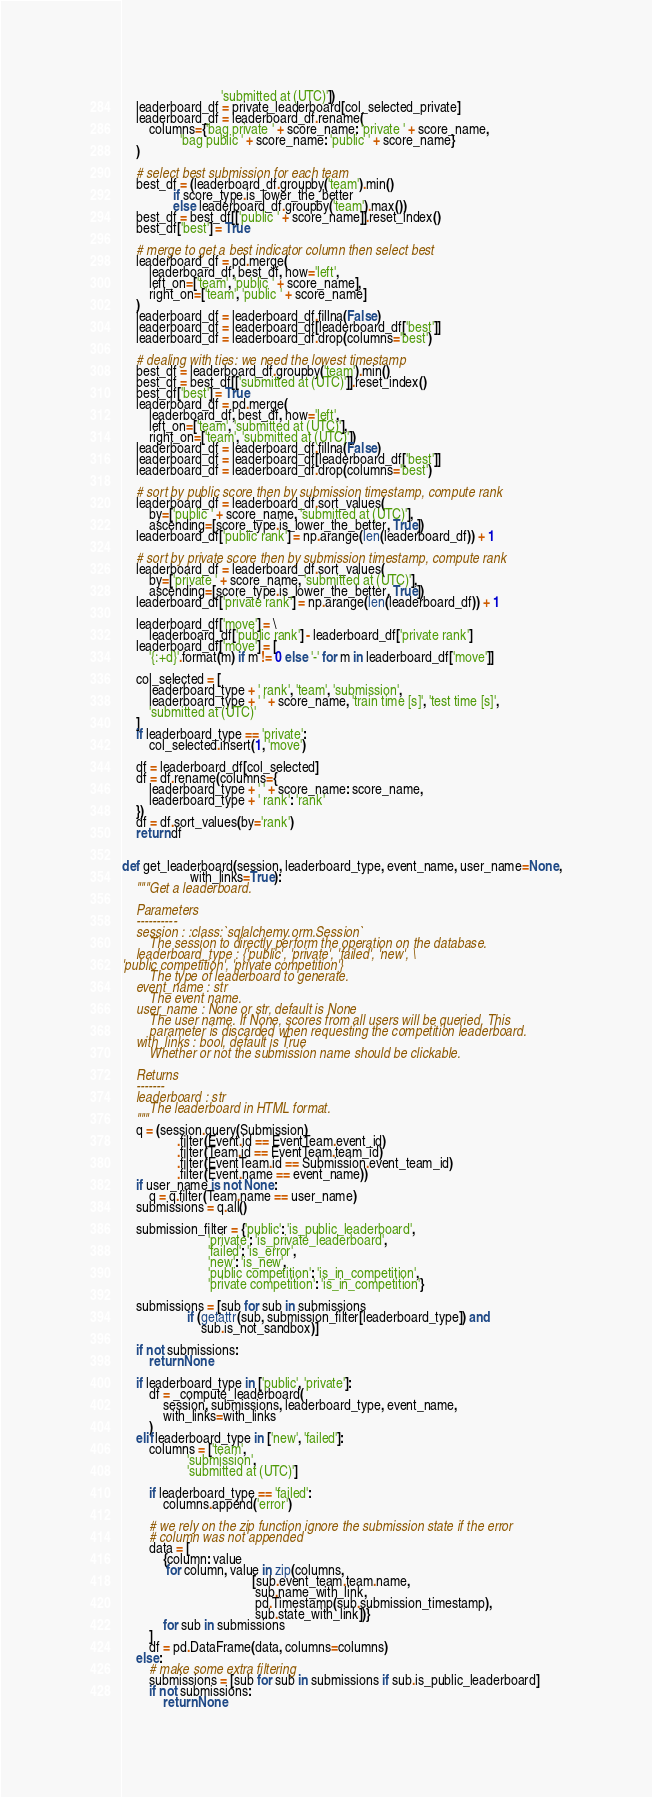<code> <loc_0><loc_0><loc_500><loc_500><_Python_>                             'submitted at (UTC)'])
    leaderboard_df = private_leaderboard[col_selected_private]
    leaderboard_df = leaderboard_df.rename(
        columns={'bag private ' + score_name: 'private ' + score_name,
                 'bag public ' + score_name: 'public ' + score_name}
    )

    # select best submission for each team
    best_df = (leaderboard_df.groupby('team').min()
               if score_type.is_lower_the_better
               else leaderboard_df.groupby('team').max())
    best_df = best_df[['public ' + score_name]].reset_index()
    best_df['best'] = True

    # merge to get a best indicator column then select best
    leaderboard_df = pd.merge(
        leaderboard_df, best_df, how='left',
        left_on=['team', 'public ' + score_name],
        right_on=['team', 'public ' + score_name]
    )
    leaderboard_df = leaderboard_df.fillna(False)
    leaderboard_df = leaderboard_df[leaderboard_df['best']]
    leaderboard_df = leaderboard_df.drop(columns='best')

    # dealing with ties: we need the lowest timestamp
    best_df = leaderboard_df.groupby('team').min()
    best_df = best_df[['submitted at (UTC)']].reset_index()
    best_df['best'] = True
    leaderboard_df = pd.merge(
        leaderboard_df, best_df, how='left',
        left_on=['team', 'submitted at (UTC)'],
        right_on=['team', 'submitted at (UTC)'])
    leaderboard_df = leaderboard_df.fillna(False)
    leaderboard_df = leaderboard_df[leaderboard_df['best']]
    leaderboard_df = leaderboard_df.drop(columns='best')

    # sort by public score then by submission timestamp, compute rank
    leaderboard_df = leaderboard_df.sort_values(
        by=['public ' + score_name, 'submitted at (UTC)'],
        ascending=[score_type.is_lower_the_better, True])
    leaderboard_df['public rank'] = np.arange(len(leaderboard_df)) + 1

    # sort by private score then by submission timestamp, compute rank
    leaderboard_df = leaderboard_df.sort_values(
        by=['private ' + score_name, 'submitted at (UTC)'],
        ascending=[score_type.is_lower_the_better, True])
    leaderboard_df['private rank'] = np.arange(len(leaderboard_df)) + 1

    leaderboard_df['move'] = \
        leaderboard_df['public rank'] - leaderboard_df['private rank']
    leaderboard_df['move'] = [
        '{:+d}'.format(m) if m != 0 else '-' for m in leaderboard_df['move']]

    col_selected = [
        leaderboard_type + ' rank', 'team', 'submission',
        leaderboard_type + ' ' + score_name, 'train time [s]', 'test time [s]',
        'submitted at (UTC)'
    ]
    if leaderboard_type == 'private':
        col_selected.insert(1, 'move')

    df = leaderboard_df[col_selected]
    df = df.rename(columns={
        leaderboard_type + ' ' + score_name: score_name,
        leaderboard_type + ' rank': 'rank'
    })
    df = df.sort_values(by='rank')
    return df


def get_leaderboard(session, leaderboard_type, event_name, user_name=None,
                    with_links=True):
    """Get a leaderboard.

    Parameters
    ----------
    session : :class:`sqlalchemy.orm.Session`
        The session to directly perform the operation on the database.
    leaderboard_type : {'public', 'private', 'failed', 'new', \
'public competition', 'private competition'}
        The type of leaderboard to generate.
    event_name : str
        The event name.
    user_name : None or str, default is None
        The user name. If None, scores from all users will be queried. This
        parameter is discarded when requesting the competition leaderboard.
    with_links : bool, default is True
        Whether or not the submission name should be clickable.

    Returns
    -------
    leaderboard : str
        The leaderboard in HTML format.
    """
    q = (session.query(Submission)
                .filter(Event.id == EventTeam.event_id)
                .filter(Team.id == EventTeam.team_id)
                .filter(EventTeam.id == Submission.event_team_id)
                .filter(Event.name == event_name))
    if user_name is not None:
        q = q.filter(Team.name == user_name)
    submissions = q.all()

    submission_filter = {'public': 'is_public_leaderboard',
                         'private': 'is_private_leaderboard',
                         'failed': 'is_error',
                         'new': 'is_new',
                         'public competition': 'is_in_competition',
                         'private competition': 'is_in_competition'}

    submissions = [sub for sub in submissions
                   if (getattr(sub, submission_filter[leaderboard_type]) and
                       sub.is_not_sandbox)]

    if not submissions:
        return None

    if leaderboard_type in ['public', 'private']:
        df = _compute_leaderboard(
            session, submissions, leaderboard_type, event_name,
            with_links=with_links
        )
    elif leaderboard_type in ['new', 'failed']:
        columns = ['team',
                   'submission',
                   'submitted at (UTC)']

        if leaderboard_type == 'failed':
            columns.append('error')

        # we rely on the zip function ignore the submission state if the error
        # column was not appended
        data = [
            {column: value
             for column, value in zip(columns,
                                      [sub.event_team.team.name,
                                       sub.name_with_link,
                                       pd.Timestamp(sub.submission_timestamp),
                                       sub.state_with_link])}
            for sub in submissions
        ]
        df = pd.DataFrame(data, columns=columns)
    else:
        # make some extra filtering
        submissions = [sub for sub in submissions if sub.is_public_leaderboard]
        if not submissions:
            return None</code> 